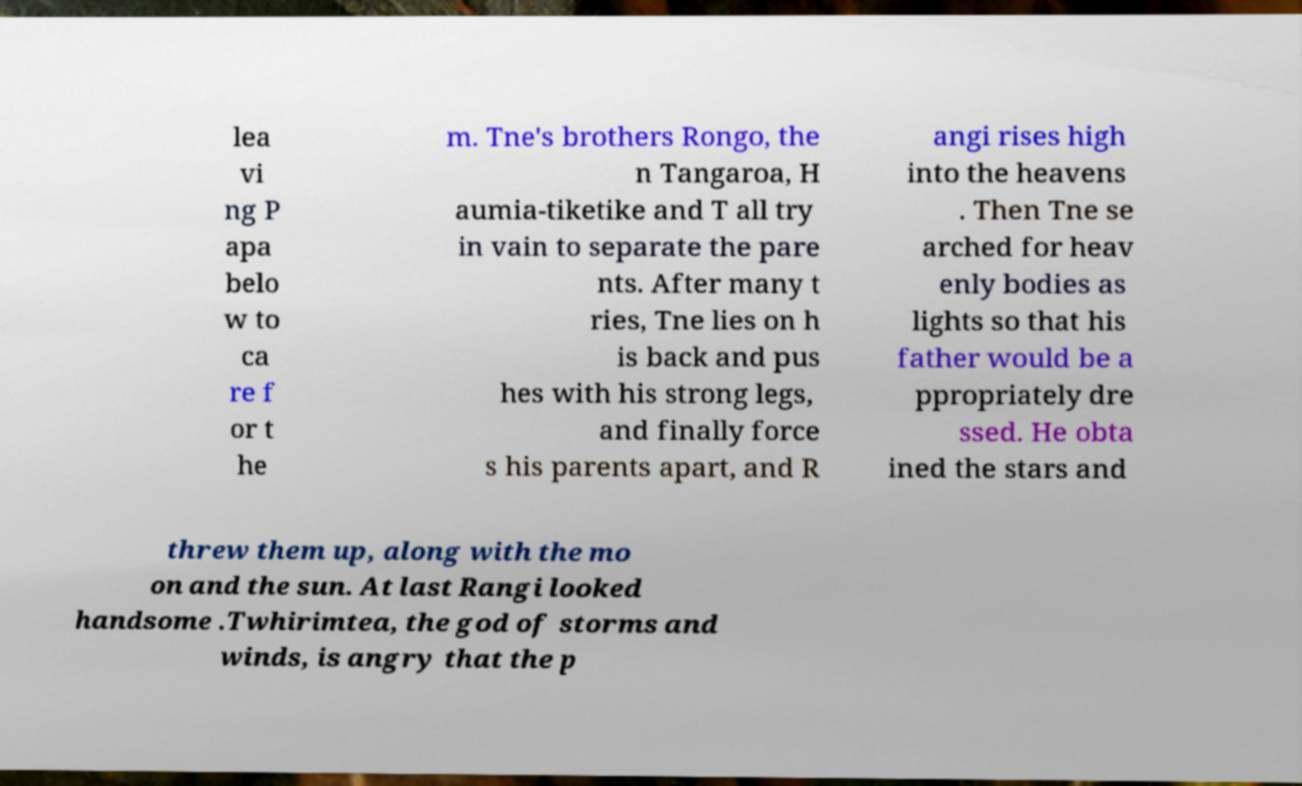For documentation purposes, I need the text within this image transcribed. Could you provide that? lea vi ng P apa belo w to ca re f or t he m. Tne's brothers Rongo, the n Tangaroa, H aumia-tiketike and T all try in vain to separate the pare nts. After many t ries, Tne lies on h is back and pus hes with his strong legs, and finally force s his parents apart, and R angi rises high into the heavens . Then Tne se arched for heav enly bodies as lights so that his father would be a ppropriately dre ssed. He obta ined the stars and threw them up, along with the mo on and the sun. At last Rangi looked handsome .Twhirimtea, the god of storms and winds, is angry that the p 